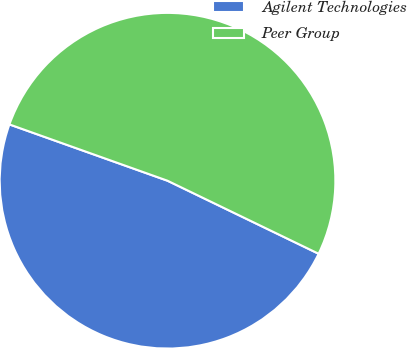<chart> <loc_0><loc_0><loc_500><loc_500><pie_chart><fcel>Agilent Technologies<fcel>Peer Group<nl><fcel>48.28%<fcel>51.72%<nl></chart> 